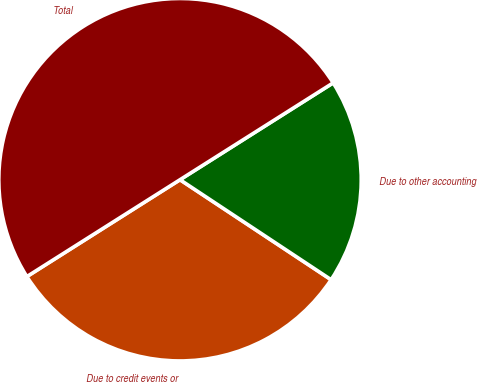Convert chart. <chart><loc_0><loc_0><loc_500><loc_500><pie_chart><fcel>Due to credit events or<fcel>Due to other accounting<fcel>Total<nl><fcel>31.72%<fcel>18.28%<fcel>50.0%<nl></chart> 